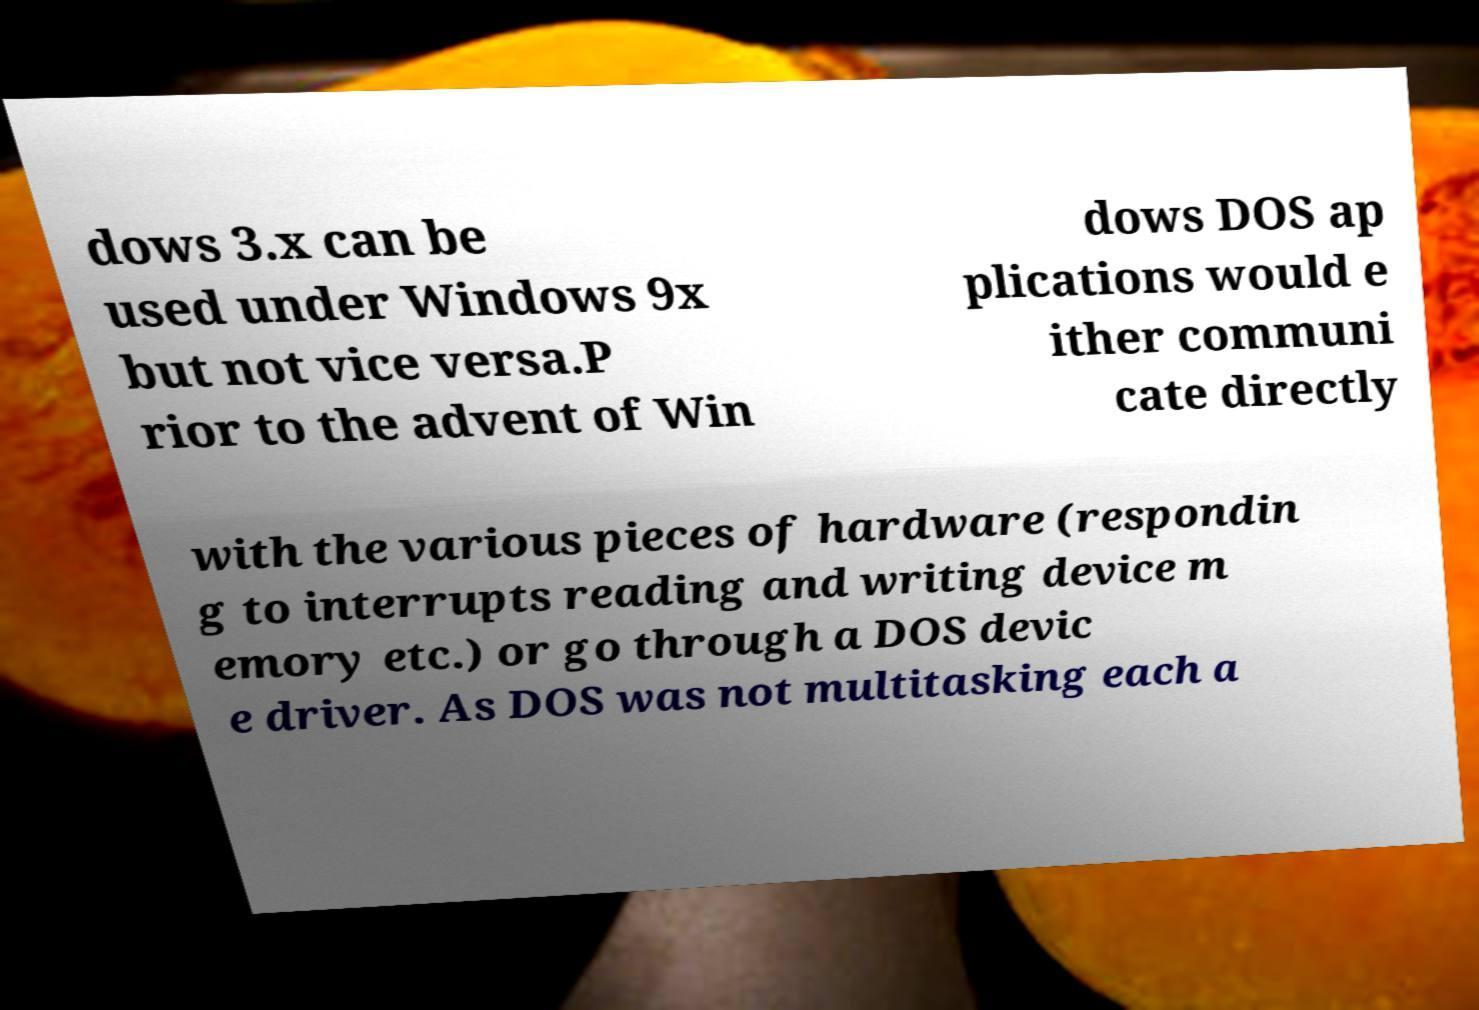Please identify and transcribe the text found in this image. dows 3.x can be used under Windows 9x but not vice versa.P rior to the advent of Win dows DOS ap plications would e ither communi cate directly with the various pieces of hardware (respondin g to interrupts reading and writing device m emory etc.) or go through a DOS devic e driver. As DOS was not multitasking each a 